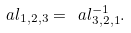<formula> <loc_0><loc_0><loc_500><loc_500>\ a l _ { 1 , 2 , 3 } = \ a l _ { 3 , 2 , 1 } ^ { - 1 } .</formula> 